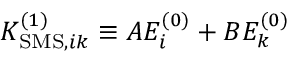Convert formula to latex. <formula><loc_0><loc_0><loc_500><loc_500>K _ { S M S , i k } ^ { ( 1 ) } \equiv A E _ { i } ^ { ( 0 ) } + B E _ { k } ^ { ( 0 ) }</formula> 